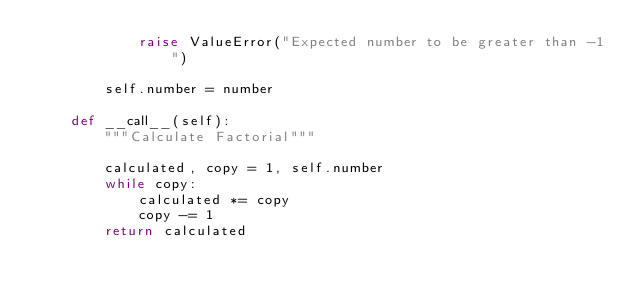<code> <loc_0><loc_0><loc_500><loc_500><_Python_>            raise ValueError("Expected number to be greater than -1")

        self.number = number

    def __call__(self):
        """Calculate Factorial"""

        calculated, copy = 1, self.number
        while copy:
            calculated *= copy
            copy -= 1
        return calculated
</code> 